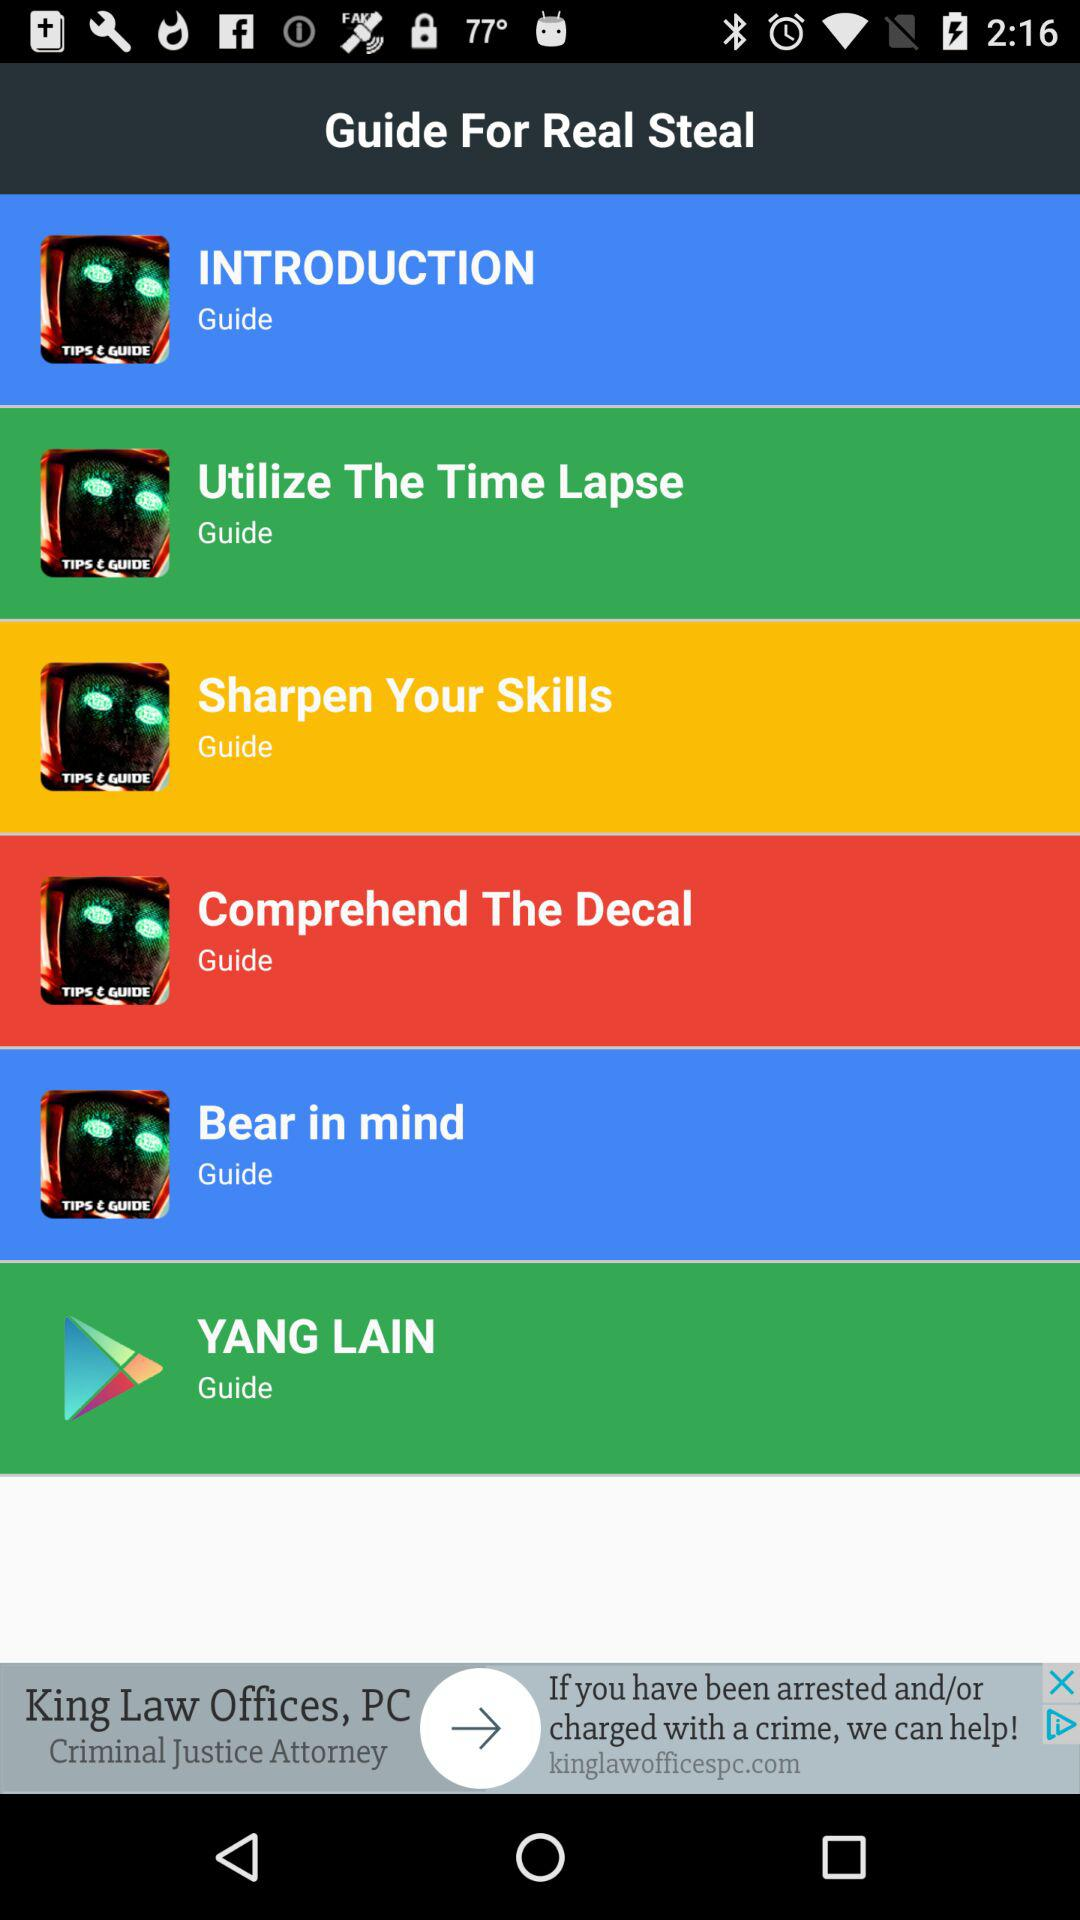How many guides are there in total?
Answer the question using a single word or phrase. 6 